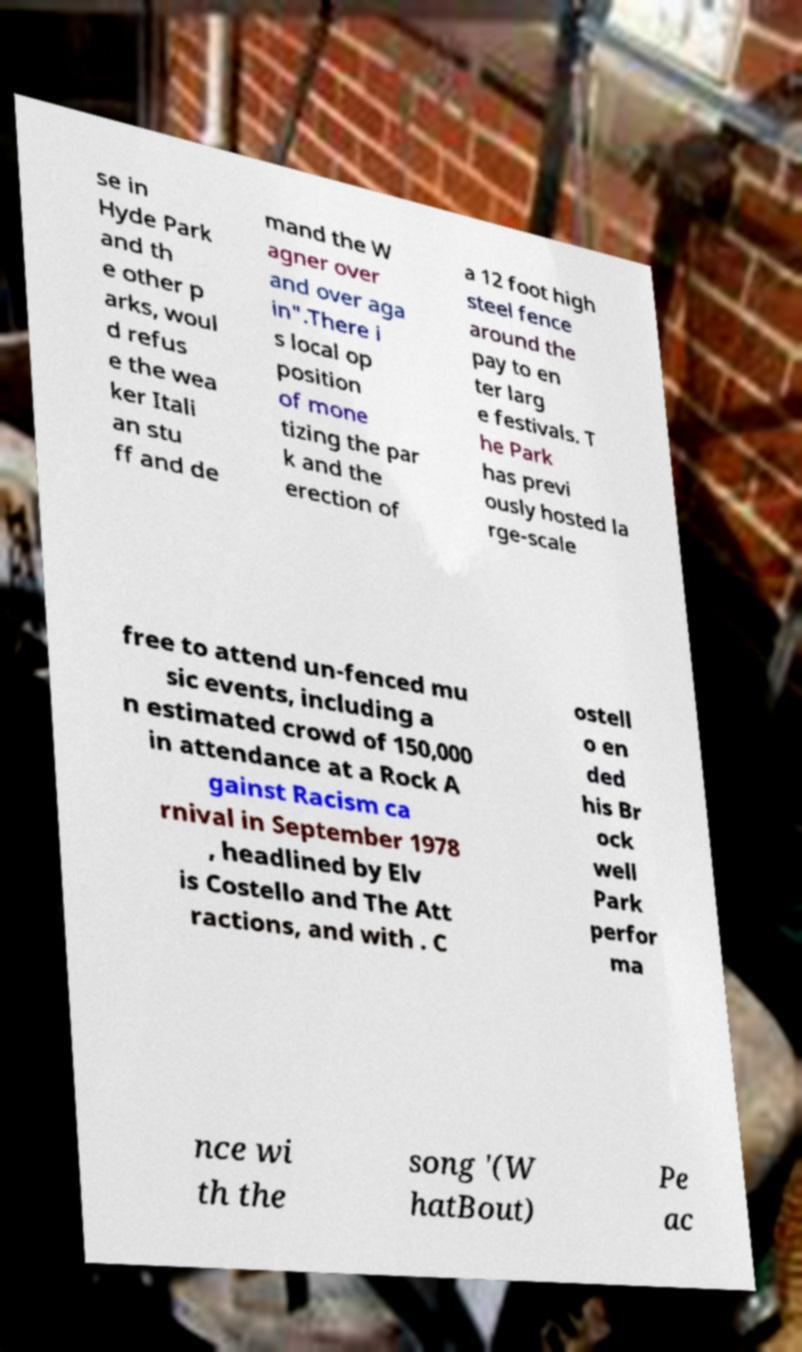Could you assist in decoding the text presented in this image and type it out clearly? se in Hyde Park and th e other p arks, woul d refus e the wea ker Itali an stu ff and de mand the W agner over and over aga in".There i s local op position of mone tizing the par k and the erection of a 12 foot high steel fence around the pay to en ter larg e festivals. T he Park has previ ously hosted la rge-scale free to attend un-fenced mu sic events, including a n estimated crowd of 150,000 in attendance at a Rock A gainst Racism ca rnival in September 1978 , headlined by Elv is Costello and The Att ractions, and with . C ostell o en ded his Br ock well Park perfor ma nce wi th the song '(W hatBout) Pe ac 